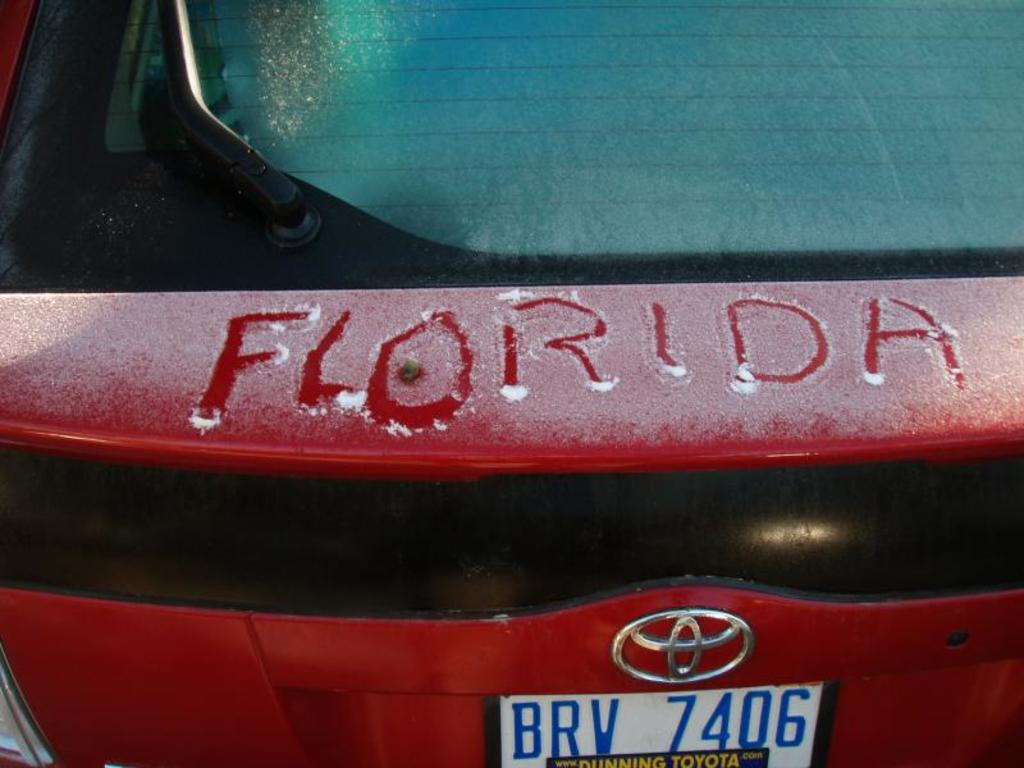What does the writing on the car tell us about the relationship between the person and the place they mentioned? The writing 'Florida' scrawled on the frosty trunk could indicate a personal connection or favorable memory associated with that location. It reflects a sentiment of affection or longing for that place, possibly hinting at past travels, a home left behind, or simply a desired vacation spot during the colder season. 